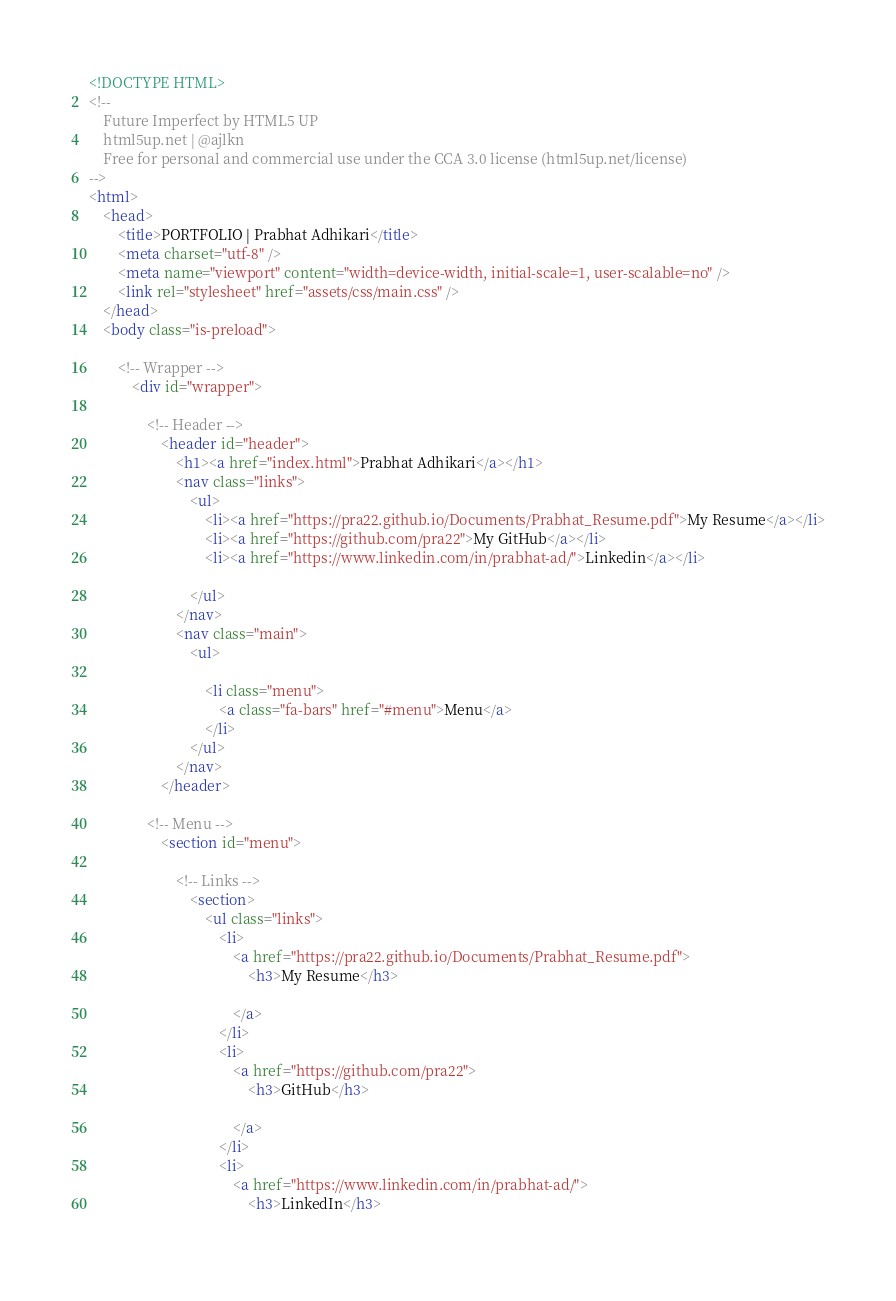Convert code to text. <code><loc_0><loc_0><loc_500><loc_500><_HTML_><!DOCTYPE HTML>
<!--
	Future Imperfect by HTML5 UP
	html5up.net | @ajlkn
	Free for personal and commercial use under the CCA 3.0 license (html5up.net/license)
-->
<html>
	<head>
		<title>PORTFOLIO | Prabhat Adhikari</title>
		<meta charset="utf-8" />
		<meta name="viewport" content="width=device-width, initial-scale=1, user-scalable=no" />
		<link rel="stylesheet" href="assets/css/main.css" />
	</head>
	<body class="is-preload">

		<!-- Wrapper -->
			<div id="wrapper">

				<!-- Header -->
					<header id="header">
						<h1><a href="index.html">Prabhat Adhikari</a></h1>
						<nav class="links">
							<ul>
								<li><a href="https://pra22.github.io/Documents/Prabhat_Resume.pdf">My Resume</a></li>
								<li><a href="https://github.com/pra22">My GitHub</a></li>
								<li><a href="https://www.linkedin.com/in/prabhat-ad/">Linkedin</a></li>
								
							</ul>
						</nav>
						<nav class="main">
							<ul>
								
								<li class="menu">
									<a class="fa-bars" href="#menu">Menu</a>
								</li>
							</ul>
						</nav>
					</header>

				<!-- Menu -->
					<section id="menu">

						<!-- Links -->
							<section>
								<ul class="links">
									<li>
										<a href="https://pra22.github.io/Documents/Prabhat_Resume.pdf">
											<h3>My Resume</h3>
											
										</a>
									</li>
									<li>
										<a href="https://github.com/pra22">
											<h3>GitHub</h3>
											
										</a>
									</li>
									<li>
										<a href="https://www.linkedin.com/in/prabhat-ad/">
											<h3>LinkedIn</h3>
											</code> 